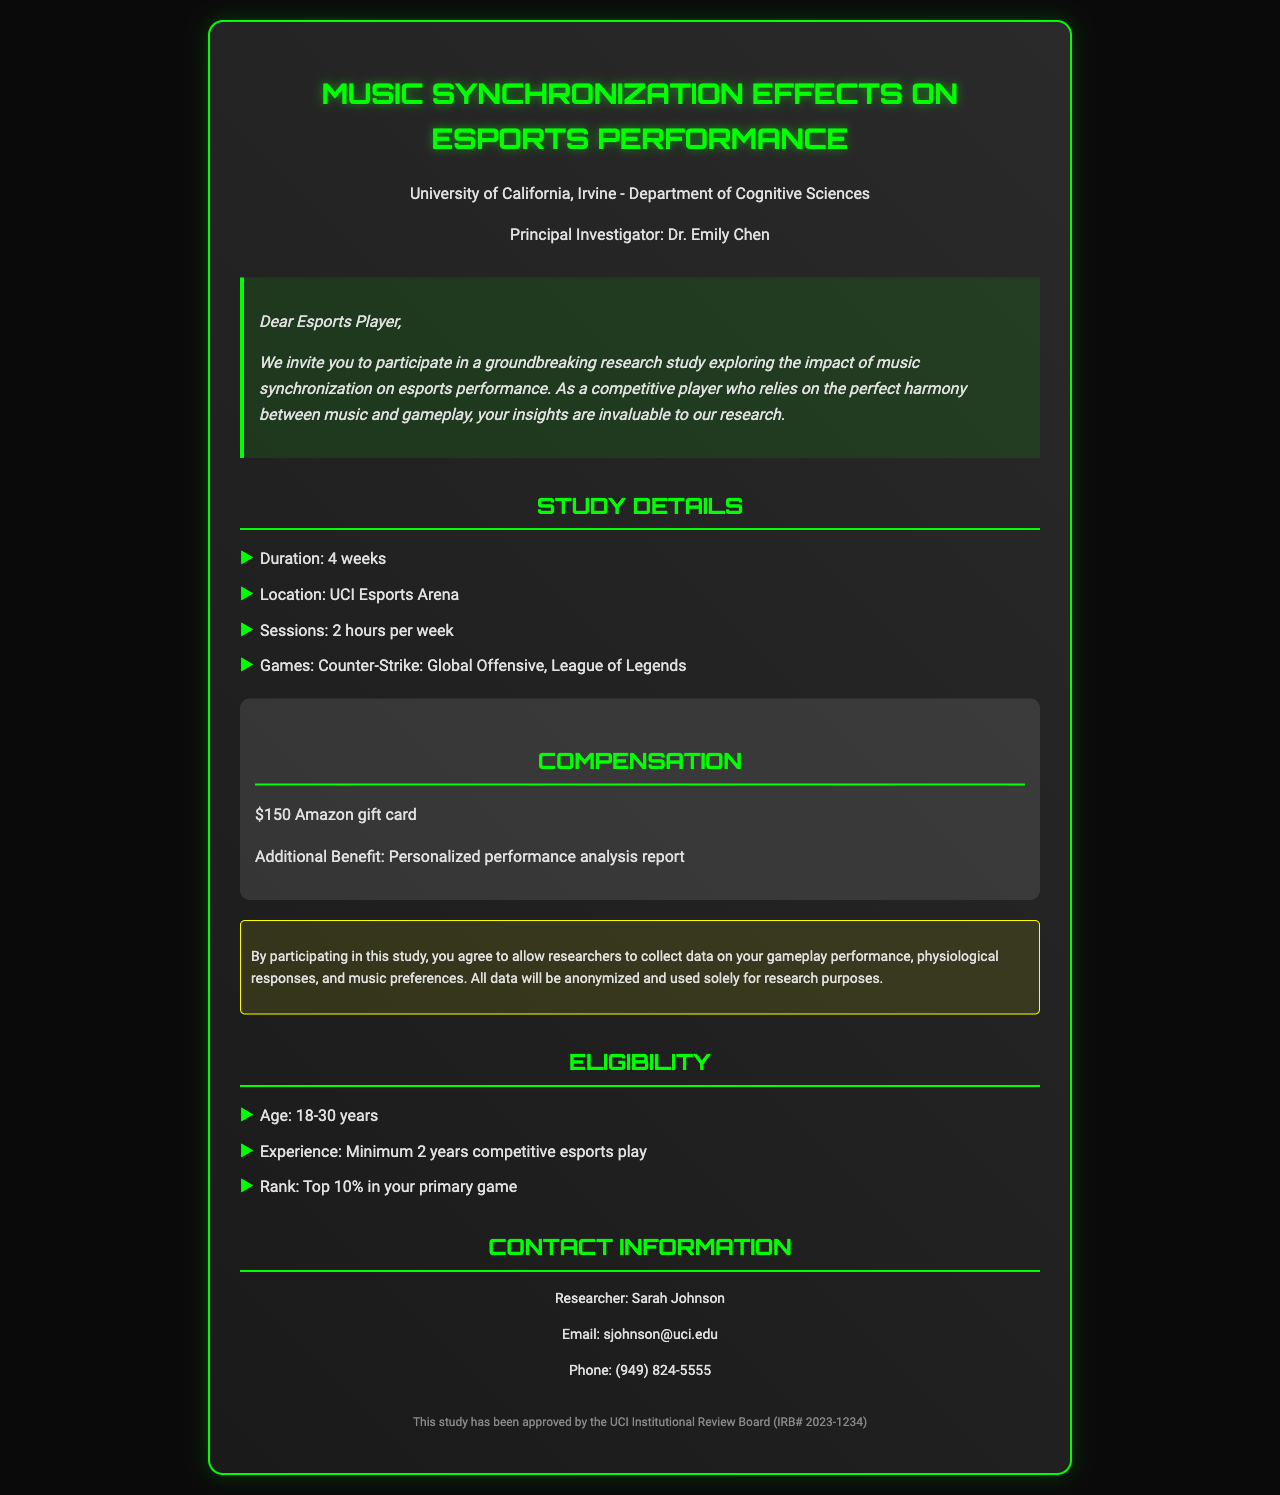What is the study's duration? The study's duration is stated in the document as 4 weeks.
Answer: 4 weeks Who is the principal investigator? The principal investigator is introduced in the document as Dr. Emily Chen.
Answer: Dr. Emily Chen What is the compensation for participating in the study? The compensation provided for participating in the study includes a $150 Amazon gift card.
Answer: $150 Amazon gift card What games are included in the research study? The document lists the games included in the study as Counter-Strike: Global Offensive and League of Legends.
Answer: Counter-Strike: Global Offensive, League of Legends What is the minimum competitive esports experience required to participate? The document specifies that a minimum of 2 years competitive esports play is required for eligibility.
Answer: Minimum 2 years competitive esports play What additional benefit do participants receive? An additional benefit stated in the document is a personalized performance analysis report.
Answer: Personalized performance analysis report What is the age range to be eligible for the study? The age range for eligibility in the study is noted as 18-30 years.
Answer: 18-30 years What is the researcher’s email address? The email address of the researcher is provided in the contact information as sjohnson@uci.edu.
Answer: sjohnson@uci.edu What does the consent form authorize researchers to collect? The consent form allows researchers to collect data on gameplay performance, physiological responses, and music preferences.
Answer: Data on gameplay performance, physiological responses, and music preferences 